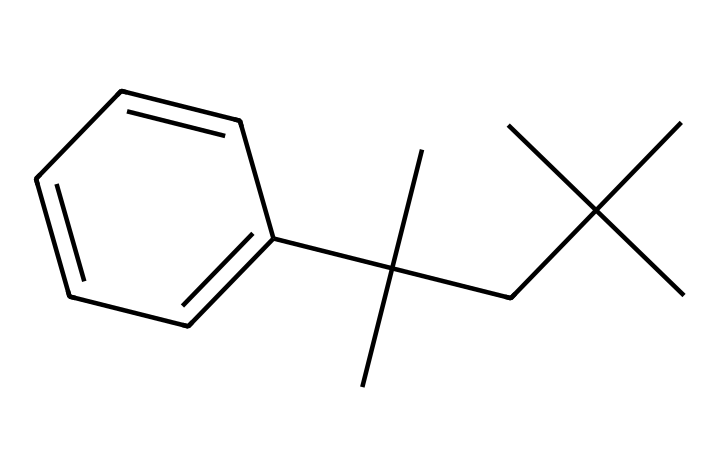What is the molecular formula of this chemical? To deduce the molecular formula, we count the number of carbon (C) and hydrogen (H) atoms in the provided SMILES representation. The structure has 15 carbon atoms and 24 hydrogen atoms, leading to the formula C15H24.
Answer: C15H24 How many aromatic rings are present in this chemical? In the chemical structure, we observe one benzene ring, indicated by the presence of alternating double bonds between the carbon atoms. Thus, there is one aromatic ring.
Answer: one What functional group is associated with polystyrene foam? Polystyrene foam has a structure comprised mainly of styrene repeating units, which consists of a benzene ring and a vinyl group (–CH=CH2). The functional group intrinsic to its polymer makeup is the hydrocarbons that lead to its plasticity.
Answer: hydrocarbons What does the presence of the benzene ring imply about the chemical’s properties? The presence of a benzene ring typically suggests that the chemical has aromatic characteristics, such as stability and hydrophobicity (tendency to repel water), affecting its behavior in applications like packaging.
Answer: aromatic characteristics Which type of plastic does this compound represent? This compound represents polystyrene, which is a type of thermoplastic. Thermoplastics can be melted and reshaped multiple times, which is an essential property for protective packaging applications.
Answer: thermoplastic What type of bonds are primarily present in this chemical? Analyzing the structure shows that the chemical primarily consists of carbon-carbon (C-C) single bonds and carbon-hydrogen (C-H) bonds, typical for hydrocarbons and polymers like polystyrene.
Answer: single bonds How does this structure affect its use in packaging? The long carbon chain and benzene ring contribute to the lightweight yet stable nature of polystyrene foam, making it an effective shock absorber and insulator for fragile items like documents.
Answer: stability and insulation 